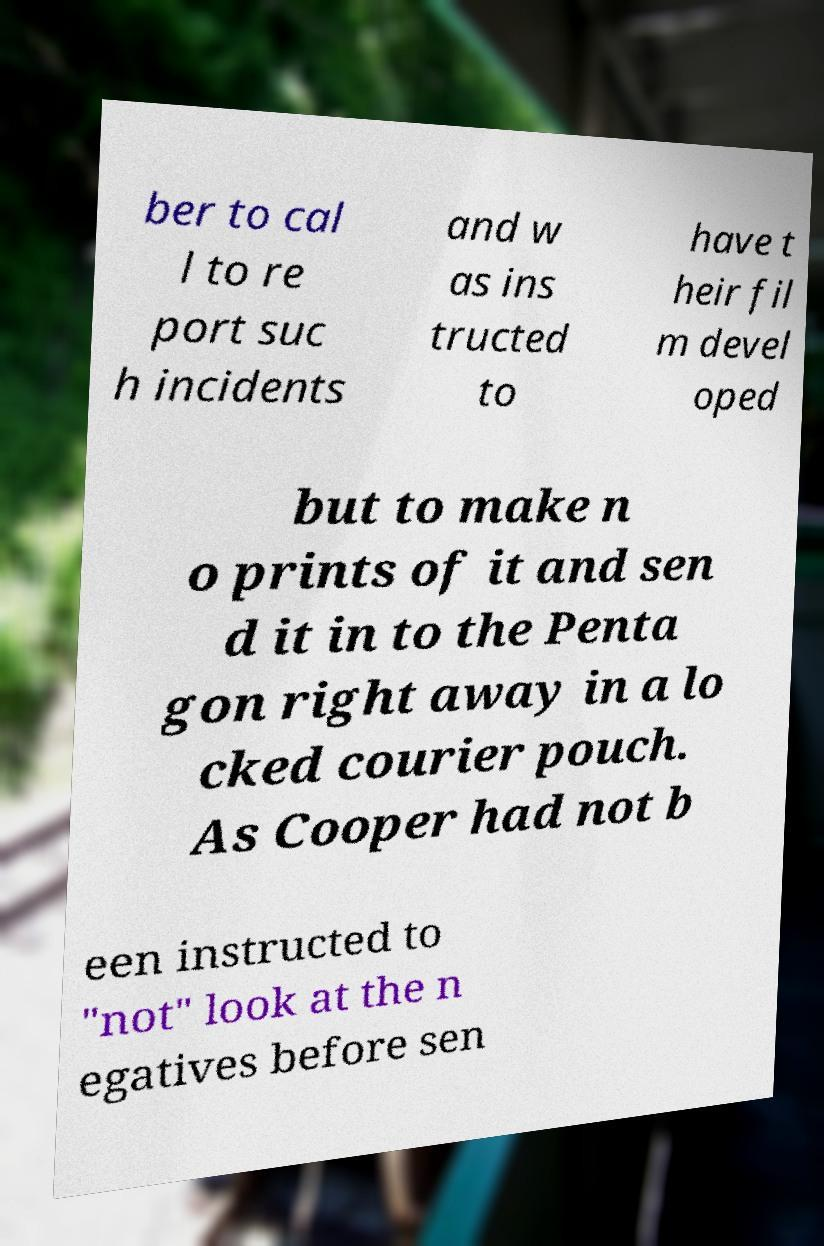I need the written content from this picture converted into text. Can you do that? ber to cal l to re port suc h incidents and w as ins tructed to have t heir fil m devel oped but to make n o prints of it and sen d it in to the Penta gon right away in a lo cked courier pouch. As Cooper had not b een instructed to "not" look at the n egatives before sen 